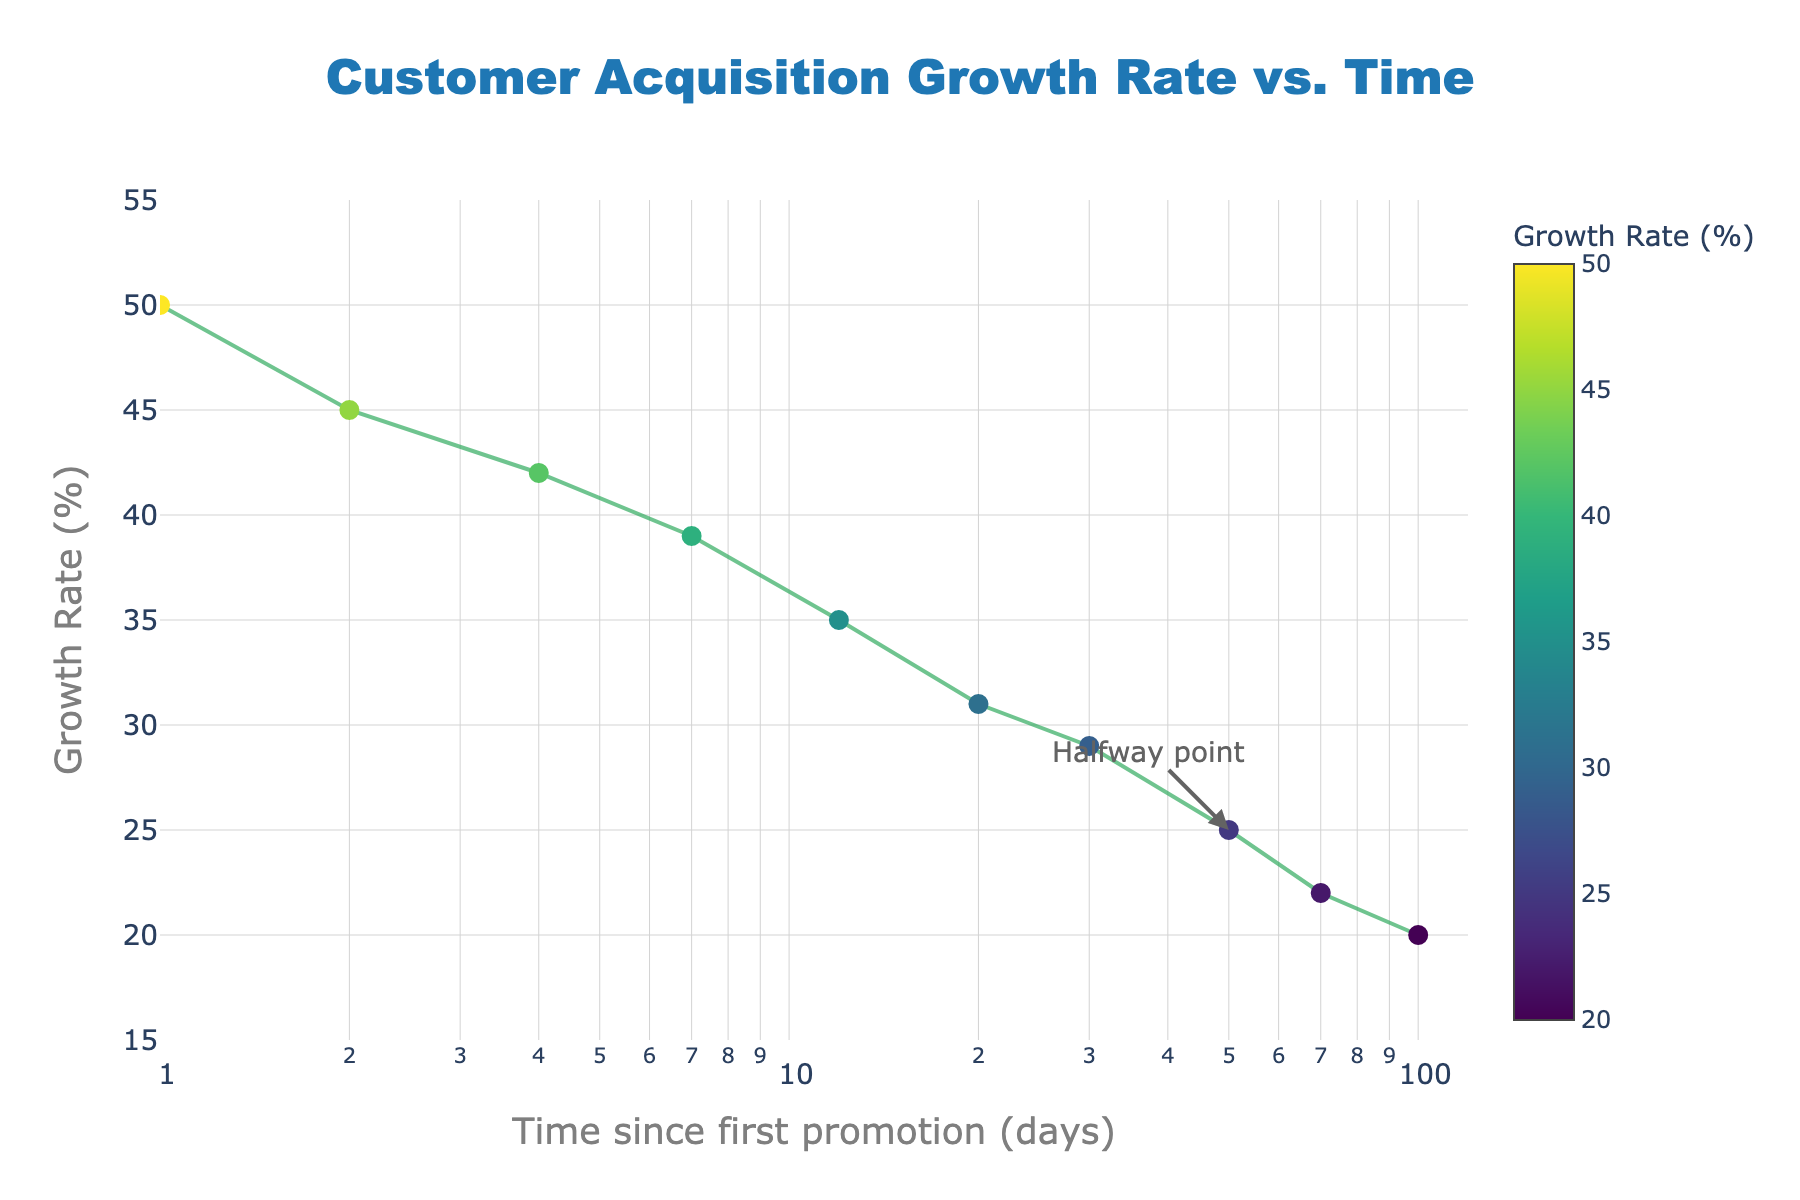What's the title of the plot? The title is usually displayed at the top of the figure. In this case, it reads "Customer Acquisition Growth Rate vs. Time".
Answer: Customer Acquisition Growth Rate vs. Time How many data points are there in the plot? There are 10 data points in the given dataset and each is visually represented by a marker in the scatter plot.
Answer: 10 What is the growth rate at time 100 days? Locate the x-axis value of 100 days and find the y-axis value at that point. The growth rate is marked as 20%.
Answer: 20% What is the trend of the growth rate over time? Observing the scatter plot, the growth rate decreases gradually as time progresses.
Answer: Decreasing At which time point does the growth rate fall to 25%? Find the growth rate value of 25% on the y-axis and trace horizontally to the corresponding x-axis value. This happens around 50 days.
Answer: 50 days What is the difference in growth rate between 1 day and 4 days? Find the growth rates at 1 day (50%) and 4 days (42%) and subtract the latter from the former (50 - 42).
Answer: 8% Compare the growth rates at 7 days and 30 days. Which is higher? Check the y-values at 7 days (39%) and 30 days (29%). 39% is higher than 29%.
Answer: 7 days Which days have a marked annotation? There is an annotation mark labeled "Halfway point" at around 50 days on the x-axis.
Answer: 50 days What is the range of the y-axis? The y-axis range is from 15% to 55%, as indicated by the axis labels and range parameter.
Answer: 15% to 55% Which data point color indicates the highest growth rate? The marker's color scale indicates higher values are darker. The highest growth rate (50%) is the darkest point at 1 day.
Answer: Darkest at 1 day 